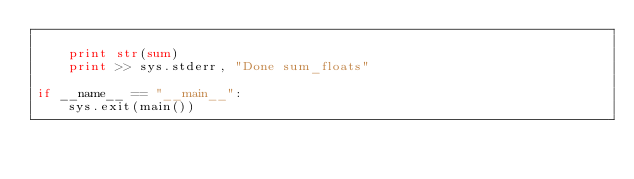Convert code to text. <code><loc_0><loc_0><loc_500><loc_500><_Python_>
    print str(sum)
    print >> sys.stderr, "Done sum_floats"

if __name__ == "__main__":
    sys.exit(main())

</code> 